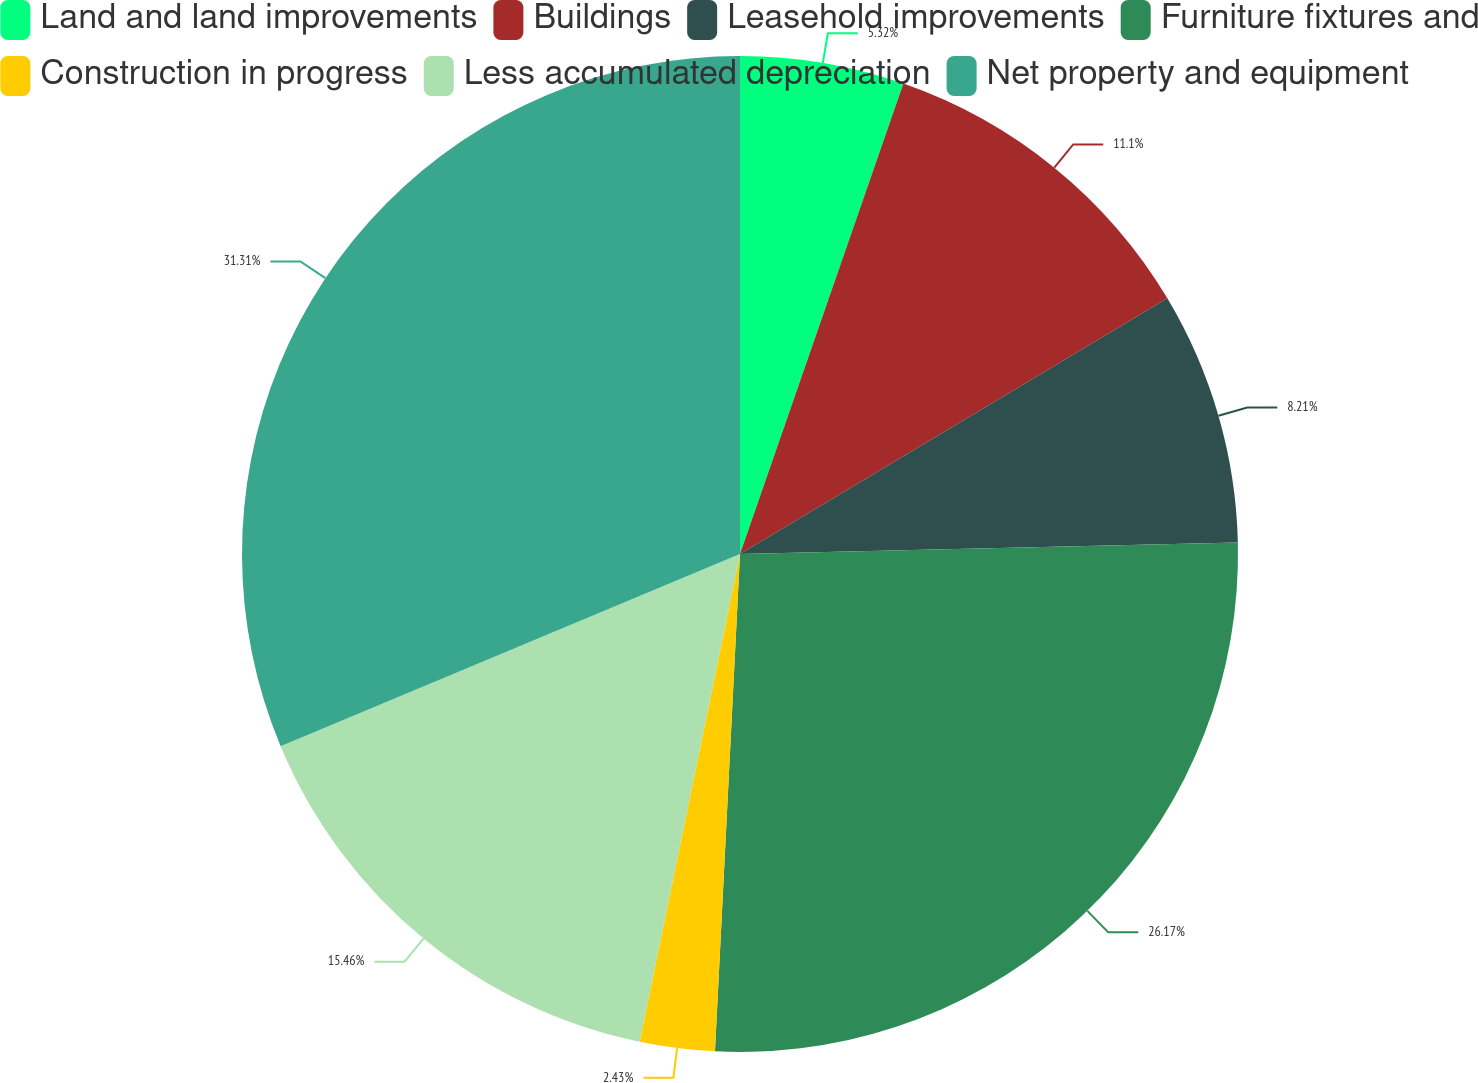Convert chart. <chart><loc_0><loc_0><loc_500><loc_500><pie_chart><fcel>Land and land improvements<fcel>Buildings<fcel>Leasehold improvements<fcel>Furniture fixtures and<fcel>Construction in progress<fcel>Less accumulated depreciation<fcel>Net property and equipment<nl><fcel>5.32%<fcel>11.1%<fcel>8.21%<fcel>26.17%<fcel>2.43%<fcel>15.46%<fcel>31.31%<nl></chart> 